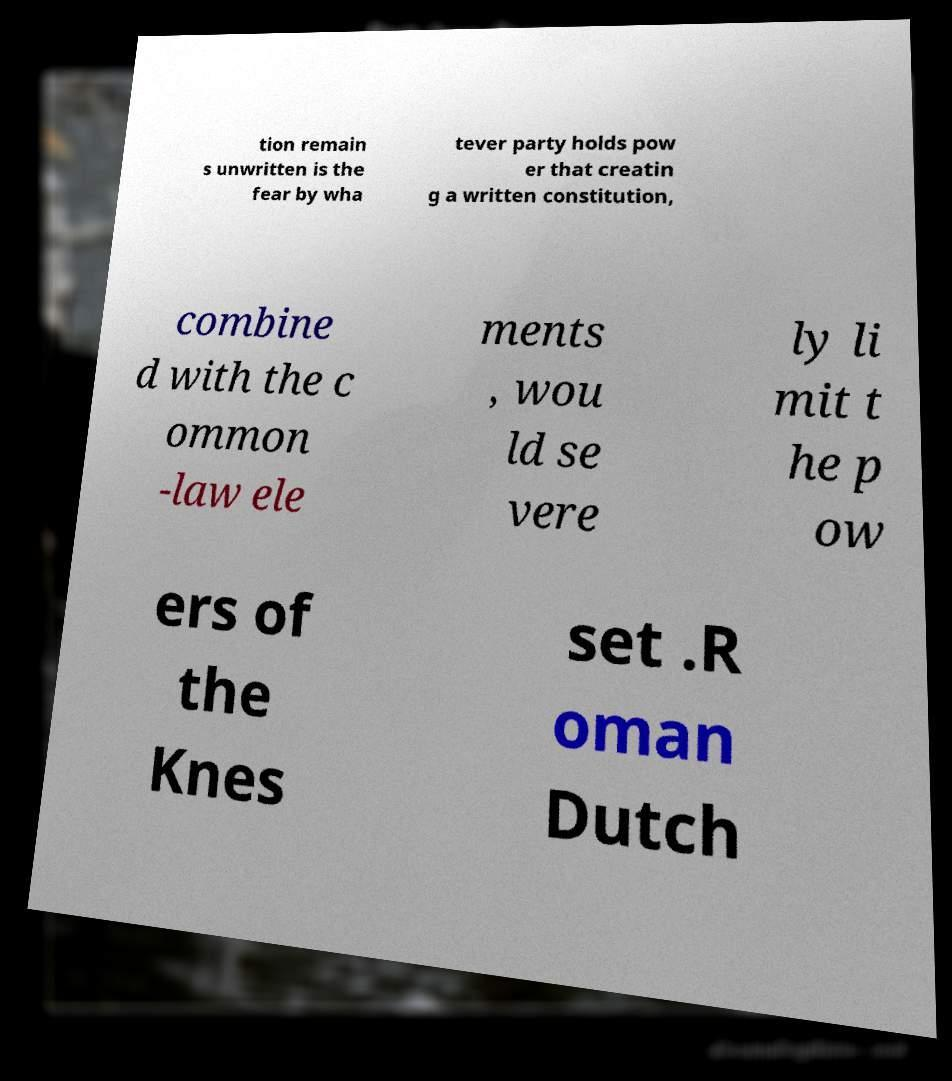Please read and relay the text visible in this image. What does it say? tion remain s unwritten is the fear by wha tever party holds pow er that creatin g a written constitution, combine d with the c ommon -law ele ments , wou ld se vere ly li mit t he p ow ers of the Knes set .R oman Dutch 